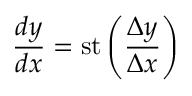<formula> <loc_0><loc_0><loc_500><loc_500>{ \frac { d y } { d x } } = s t \left ( { \frac { \Delta y } { \Delta x } } \right )</formula> 